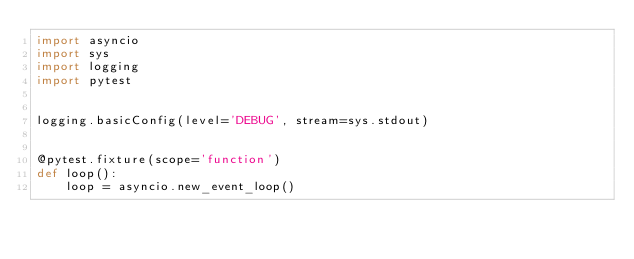<code> <loc_0><loc_0><loc_500><loc_500><_Python_>import asyncio
import sys
import logging
import pytest


logging.basicConfig(level='DEBUG', stream=sys.stdout)


@pytest.fixture(scope='function')
def loop():
    loop = asyncio.new_event_loop()</code> 